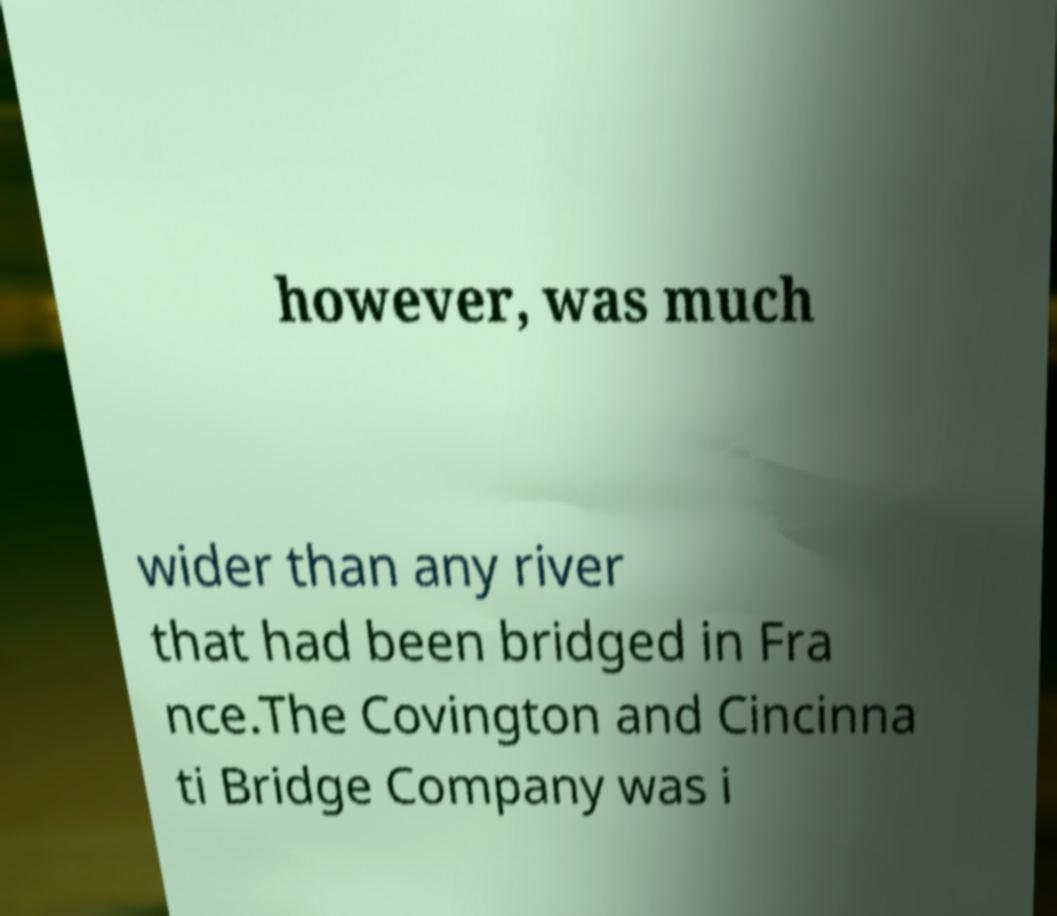There's text embedded in this image that I need extracted. Can you transcribe it verbatim? however, was much wider than any river that had been bridged in Fra nce.The Covington and Cincinna ti Bridge Company was i 